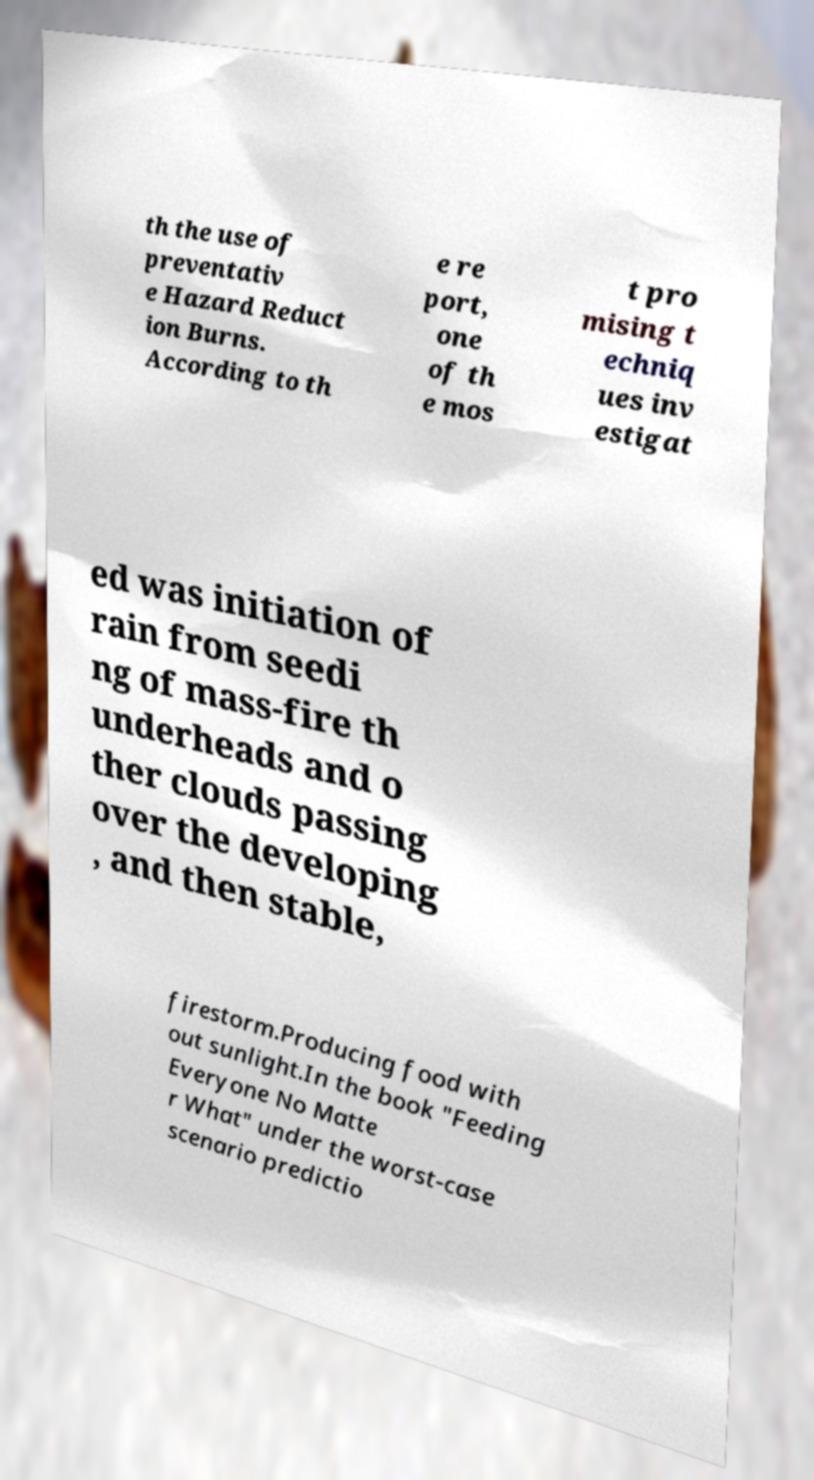Can you read and provide the text displayed in the image?This photo seems to have some interesting text. Can you extract and type it out for me? th the use of preventativ e Hazard Reduct ion Burns. According to th e re port, one of th e mos t pro mising t echniq ues inv estigat ed was initiation of rain from seedi ng of mass-fire th underheads and o ther clouds passing over the developing , and then stable, firestorm.Producing food with out sunlight.In the book "Feeding Everyone No Matte r What" under the worst-case scenario predictio 